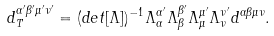Convert formula to latex. <formula><loc_0><loc_0><loc_500><loc_500>d _ { T } ^ { \alpha ^ { \prime } \beta ^ { \prime } \mu ^ { \prime } \nu ^ { \prime } } = ( d e t [ \Lambda ] ) ^ { - 1 } \Lambda ^ { \alpha ^ { \prime } } _ { \alpha } \Lambda ^ { \beta ^ { \prime } } _ { \beta } \Lambda ^ { \mu ^ { \prime } } _ { \mu } \Lambda ^ { \nu ^ { \prime } } _ { \nu } d ^ { \alpha \beta \mu \nu } .</formula> 